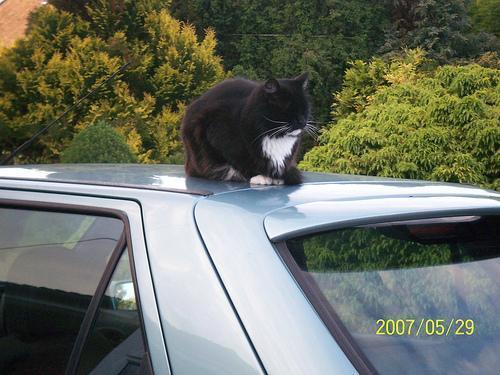How many cats are in this photo?
Give a very brief answer. 1. 